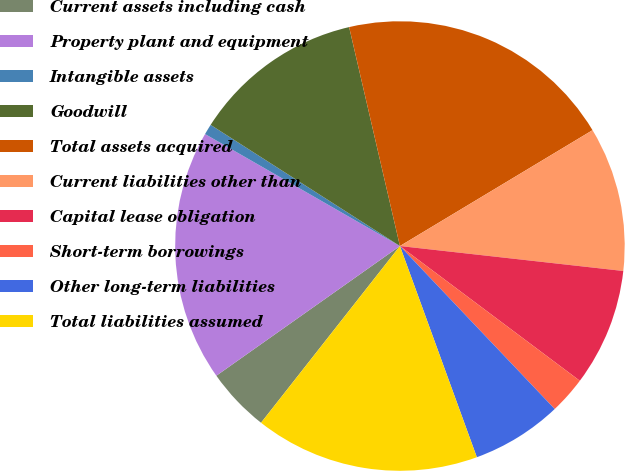<chart> <loc_0><loc_0><loc_500><loc_500><pie_chart><fcel>Current assets including cash<fcel>Property plant and equipment<fcel>Intangible assets<fcel>Goodwill<fcel>Total assets acquired<fcel>Current liabilities other than<fcel>Capital lease obligation<fcel>Short-term borrowings<fcel>Other long-term liabilities<fcel>Total liabilities assumed<nl><fcel>4.61%<fcel>18.09%<fcel>0.76%<fcel>12.31%<fcel>20.01%<fcel>10.39%<fcel>8.46%<fcel>2.68%<fcel>6.53%<fcel>16.16%<nl></chart> 